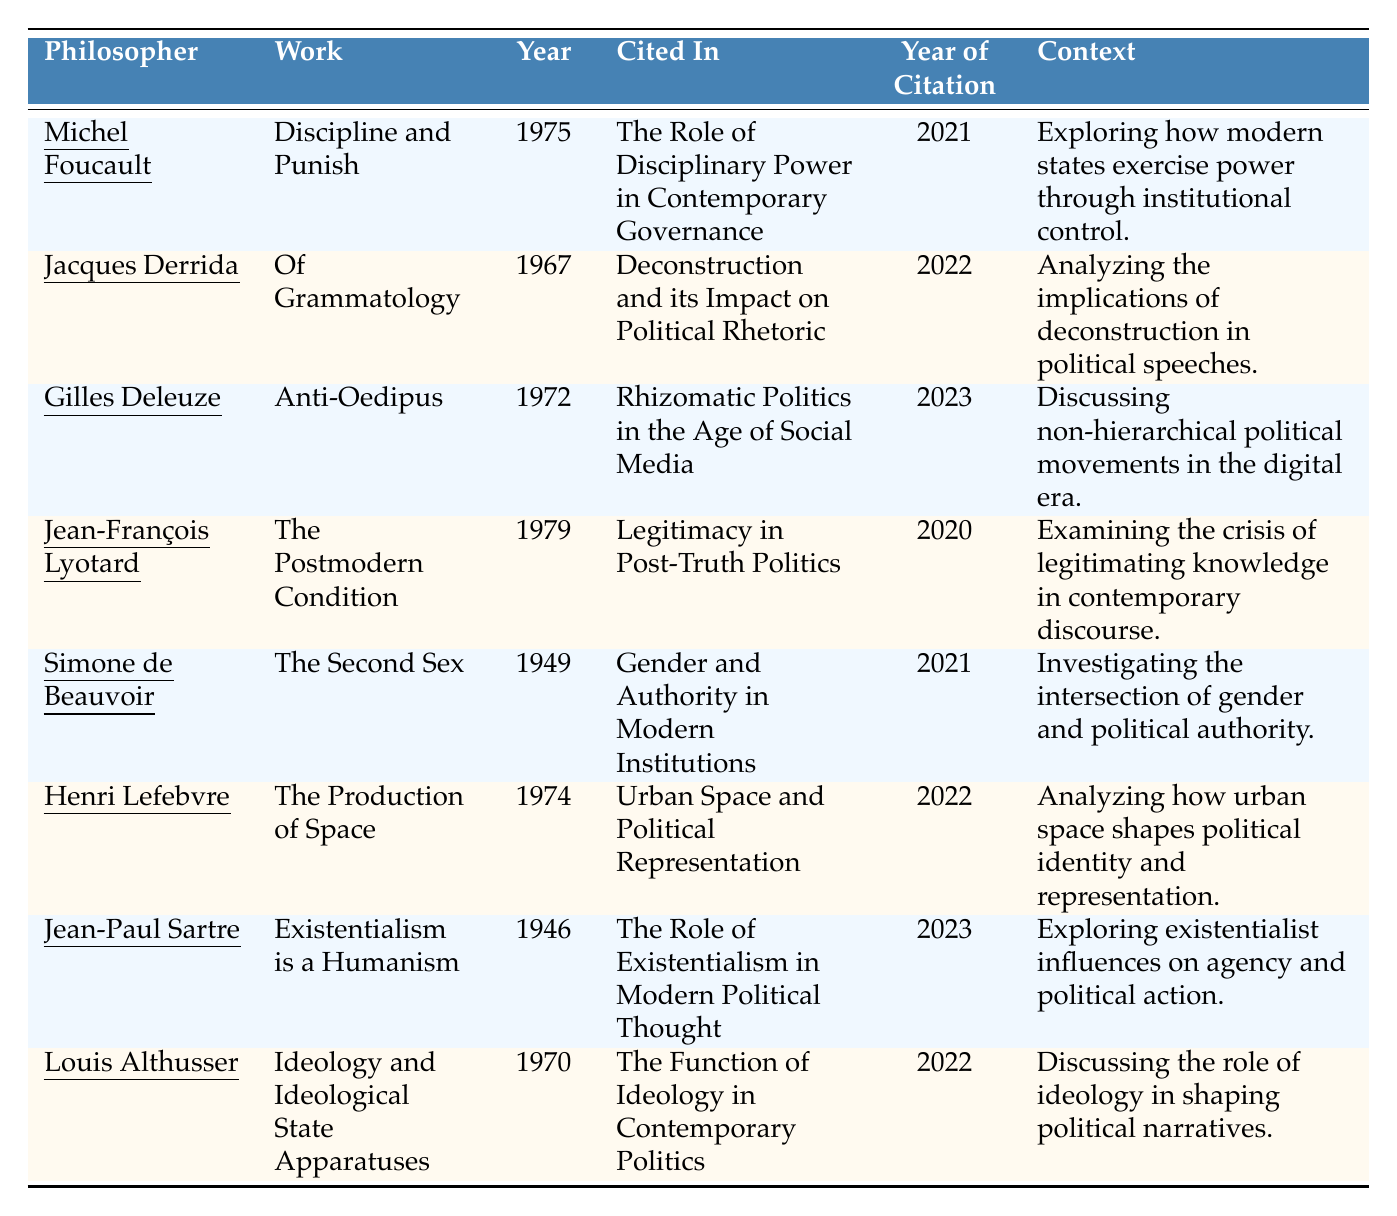What is the most recent work cited in the table? The last citation year mentioned is 2023. That work is "Rhizomatic Politics in the Age of Social Media," cited from Gilles Deleuze's "Anti-Oedipus."
Answer: Rhizomatic Politics in the Age of Social Media How many philosophers cited their work after 2020? The works cited after 2020 are from Michel Foucault (2021), Jacques Derrida (2022), Gilles Deleuze (2023), Jean-François Lyotard (2020), Simone de Beauvoir (2021), Henri Lefebvre (2022), Jean-Paul Sartre (2023), and Louis Althusser (2022). This totals 8 philosophers.
Answer: 8 Which philosopher's work is cited in the context of urban space? The context about urban space is related to Henri Lefebvre's work "The Production of Space."
Answer: Henri Lefebvre Is "The Second Sex" cited in the context of authority? Yes, it is cited in the context of exploring the intersection of gender and political authority.
Answer: Yes What is the average year of the philosophical works cited? The years of the works cited are 1975, 1967, 1972, 1979, 1949, 1974, 1946, and 1970. Adding them gives 1975 + 1967 + 1972 + 1979 + 1949 + 1974 + 1946 + 1970 = 15862, and dividing by 8 gives an average year of 1982.75.
Answer: 1982.75 Which philosopher has an existentialist influence mentioned in modern political thought? Jean-Paul Sartre's work "Existentialism is a Humanism" discusses existentialist influences on agency and political action.
Answer: Jean-Paul Sartre Are there more works cited related to ideology or gender? The works related to ideology are Louis Althusser's "Ideology and Ideological State Apparatuses" and the context is about ideology in contemporary politics, while the work related to gender is Simone de Beauvoir's "The Second Sex" in the context of gender and authority. Both have one citation, hence they are equal.
Answer: They are equal Which philosopher's work relates to post-truth politics? Jean-François Lyotard's "The Postmodern Condition" relates to legitimacy in post-truth politics.
Answer: Jean-François Lyotard In which year was "Of Grammatology" published? "Of Grammatology" was published in 1967 according to the table.
Answer: 1967 What context is associated with the work "Discipline and Punish"? The context for "Discipline and Punish" is exploring how modern states exercise power through institutional control.
Answer: Exploring how modern states exercise power through institutional control 